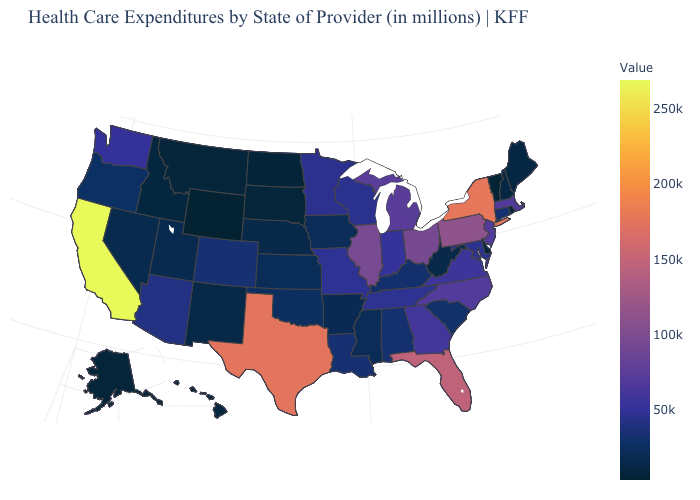Among the states that border Alabama , does Mississippi have the lowest value?
Quick response, please. Yes. Does the map have missing data?
Give a very brief answer. No. Among the states that border New Hampshire , which have the highest value?
Keep it brief. Massachusetts. Which states have the highest value in the USA?
Answer briefly. California. 